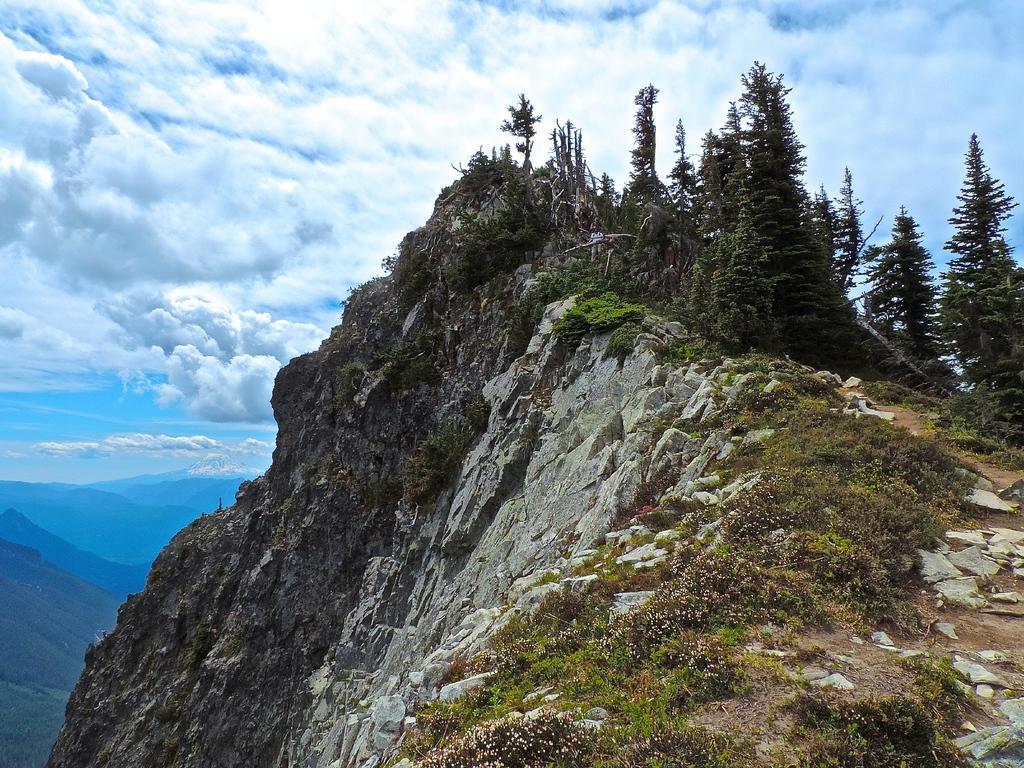Please provide a concise description of this image. In this picture I can see there is a mountain here and there are plants, trees. In the backdrop there are some more mountains and the sky is clear. 